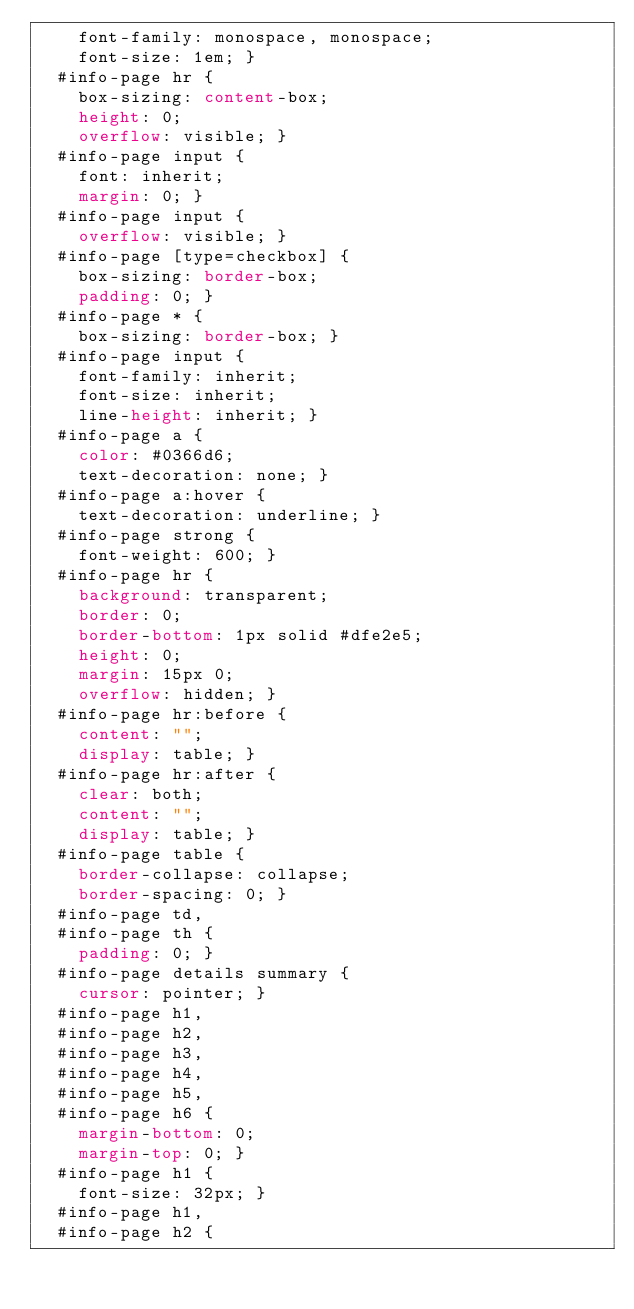<code> <loc_0><loc_0><loc_500><loc_500><_CSS_>    font-family: monospace, monospace;
    font-size: 1em; }
  #info-page hr {
    box-sizing: content-box;
    height: 0;
    overflow: visible; }
  #info-page input {
    font: inherit;
    margin: 0; }
  #info-page input {
    overflow: visible; }
  #info-page [type=checkbox] {
    box-sizing: border-box;
    padding: 0; }
  #info-page * {
    box-sizing: border-box; }
  #info-page input {
    font-family: inherit;
    font-size: inherit;
    line-height: inherit; }
  #info-page a {
    color: #0366d6;
    text-decoration: none; }
  #info-page a:hover {
    text-decoration: underline; }
  #info-page strong {
    font-weight: 600; }
  #info-page hr {
    background: transparent;
    border: 0;
    border-bottom: 1px solid #dfe2e5;
    height: 0;
    margin: 15px 0;
    overflow: hidden; }
  #info-page hr:before {
    content: "";
    display: table; }
  #info-page hr:after {
    clear: both;
    content: "";
    display: table; }
  #info-page table {
    border-collapse: collapse;
    border-spacing: 0; }
  #info-page td,
  #info-page th {
    padding: 0; }
  #info-page details summary {
    cursor: pointer; }
  #info-page h1,
  #info-page h2,
  #info-page h3,
  #info-page h4,
  #info-page h5,
  #info-page h6 {
    margin-bottom: 0;
    margin-top: 0; }
  #info-page h1 {
    font-size: 32px; }
  #info-page h1,
  #info-page h2 {</code> 